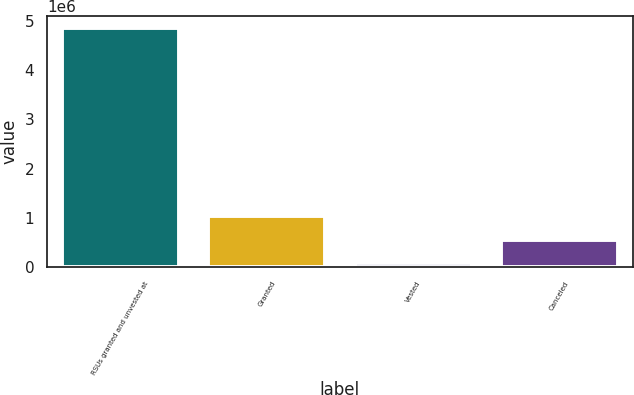<chart> <loc_0><loc_0><loc_500><loc_500><bar_chart><fcel>RSUs granted and unvested at<fcel>Granted<fcel>Vested<fcel>Canceled<nl><fcel>4.8621e+06<fcel>1.03422e+06<fcel>77250<fcel>555735<nl></chart> 